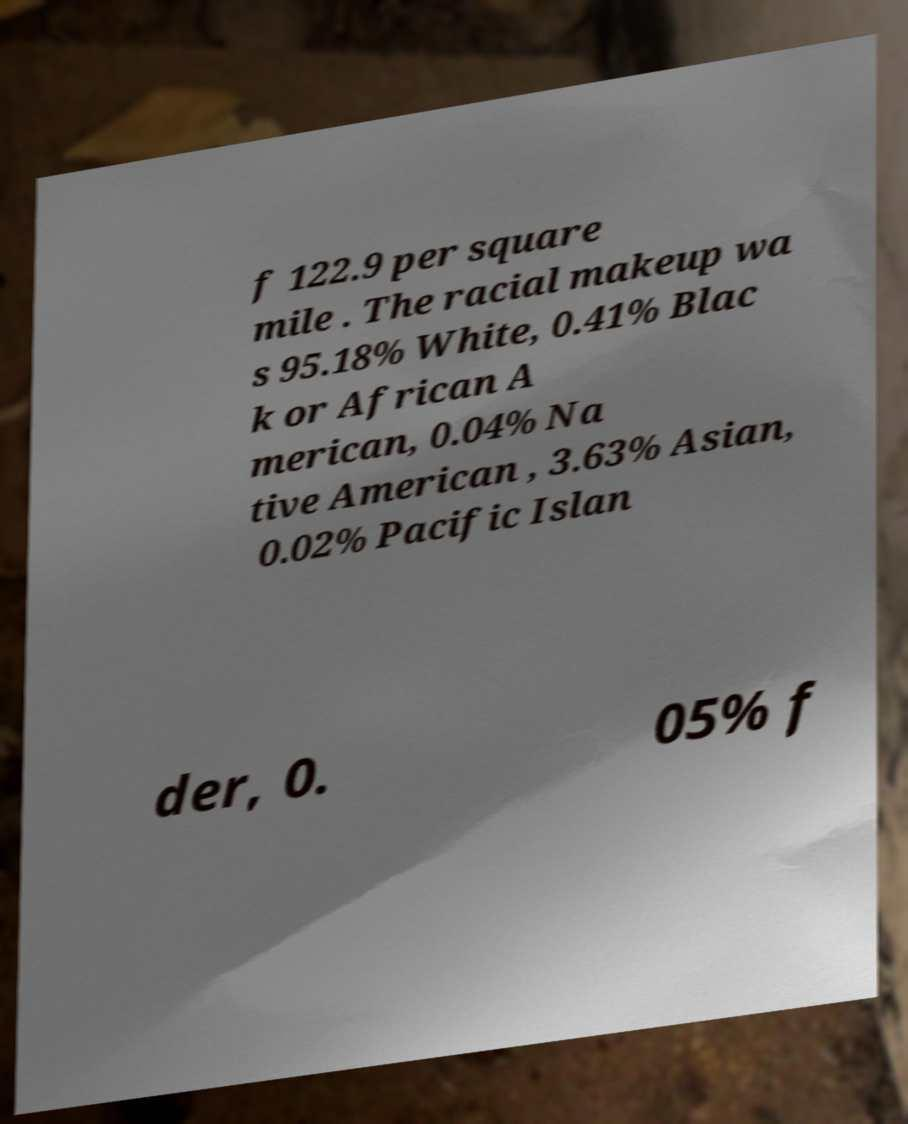I need the written content from this picture converted into text. Can you do that? f 122.9 per square mile . The racial makeup wa s 95.18% White, 0.41% Blac k or African A merican, 0.04% Na tive American , 3.63% Asian, 0.02% Pacific Islan der, 0. 05% f 